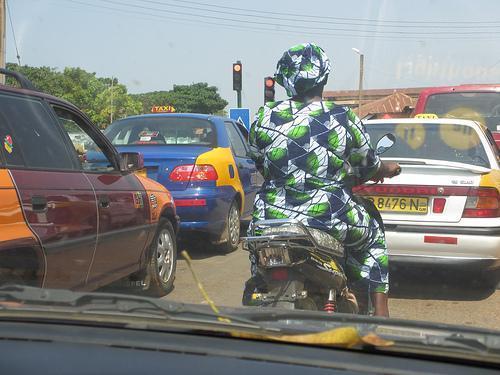How many people are there on a motorcycle?
Give a very brief answer. 1. 